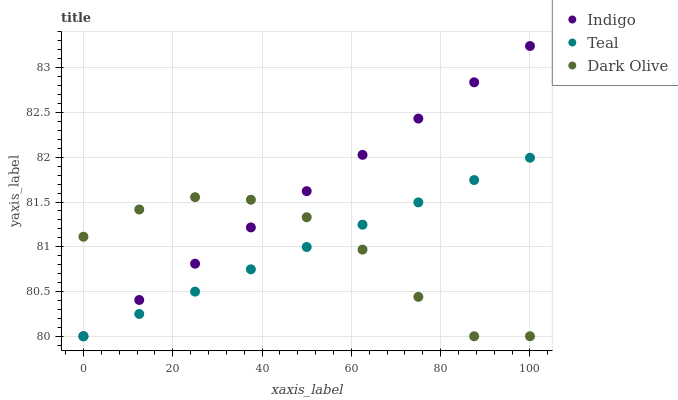Does Dark Olive have the minimum area under the curve?
Answer yes or no. Yes. Does Indigo have the maximum area under the curve?
Answer yes or no. Yes. Does Teal have the minimum area under the curve?
Answer yes or no. No. Does Teal have the maximum area under the curve?
Answer yes or no. No. Is Indigo the smoothest?
Answer yes or no. Yes. Is Dark Olive the roughest?
Answer yes or no. Yes. Is Teal the smoothest?
Answer yes or no. No. Is Teal the roughest?
Answer yes or no. No. Does Dark Olive have the lowest value?
Answer yes or no. Yes. Does Indigo have the highest value?
Answer yes or no. Yes. Does Teal have the highest value?
Answer yes or no. No. Does Indigo intersect Dark Olive?
Answer yes or no. Yes. Is Indigo less than Dark Olive?
Answer yes or no. No. Is Indigo greater than Dark Olive?
Answer yes or no. No. 